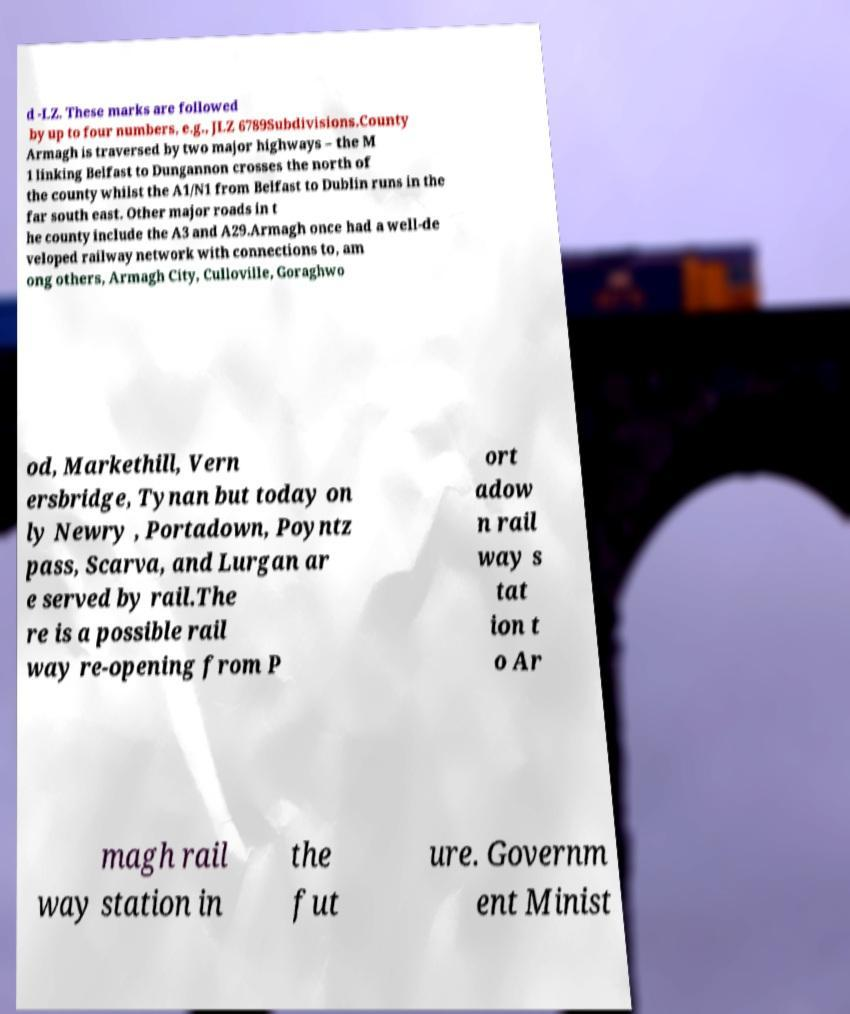Can you read and provide the text displayed in the image?This photo seems to have some interesting text. Can you extract and type it out for me? d -LZ. These marks are followed by up to four numbers, e.g., JLZ 6789Subdivisions.County Armagh is traversed by two major highways – the M 1 linking Belfast to Dungannon crosses the north of the county whilst the A1/N1 from Belfast to Dublin runs in the far south east. Other major roads in t he county include the A3 and A29.Armagh once had a well-de veloped railway network with connections to, am ong others, Armagh City, Culloville, Goraghwo od, Markethill, Vern ersbridge, Tynan but today on ly Newry , Portadown, Poyntz pass, Scarva, and Lurgan ar e served by rail.The re is a possible rail way re-opening from P ort adow n rail way s tat ion t o Ar magh rail way station in the fut ure. Governm ent Minist 